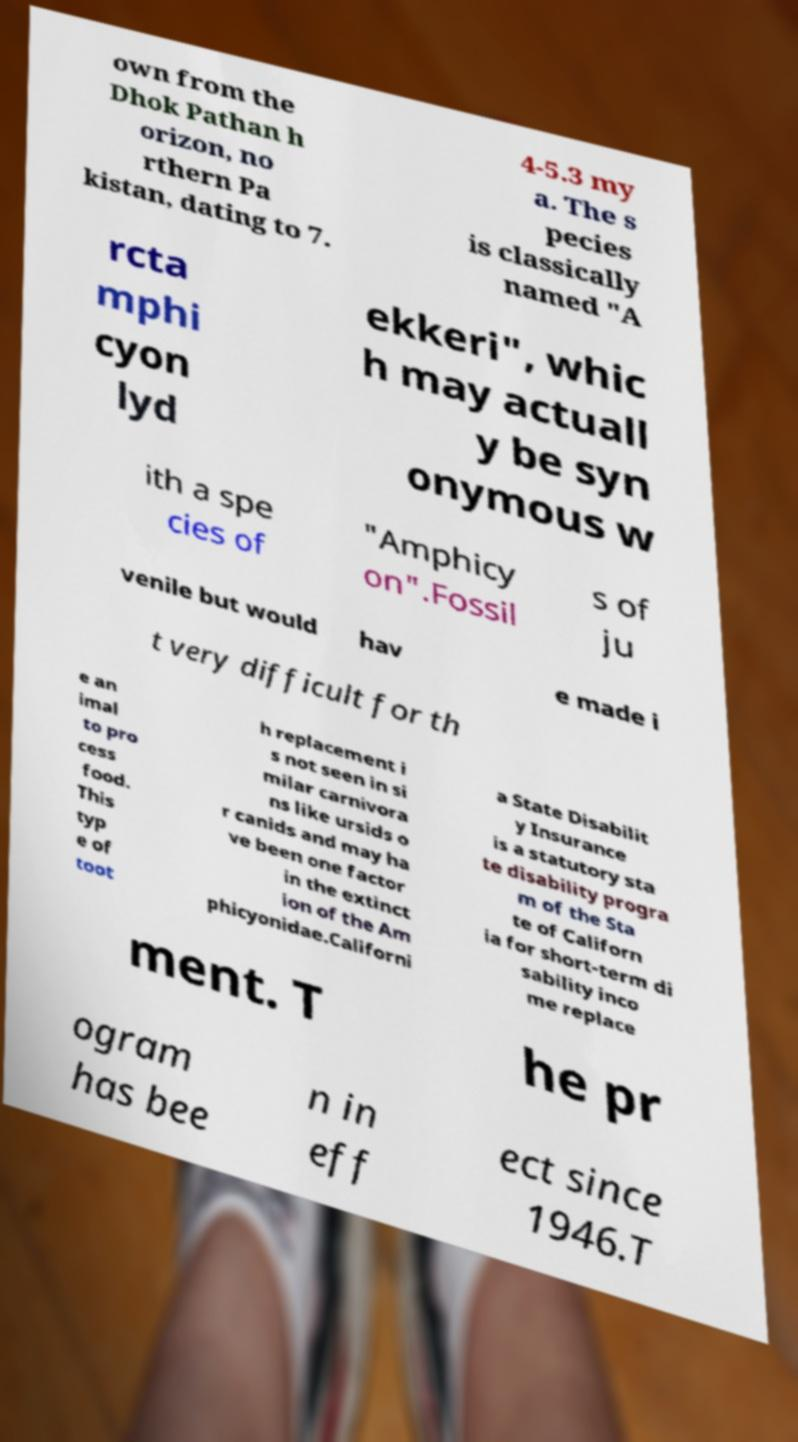Could you assist in decoding the text presented in this image and type it out clearly? own from the Dhok Pathan h orizon, no rthern Pa kistan, dating to 7. 4-5.3 my a. The s pecies is classically named "A rcta mphi cyon lyd ekkeri", whic h may actuall y be syn onymous w ith a spe cies of "Amphicy on".Fossil s of ju venile but would hav e made i t very difficult for th e an imal to pro cess food. This typ e of toot h replacement i s not seen in si milar carnivora ns like ursids o r canids and may ha ve been one factor in the extinct ion of the Am phicyonidae.Californi a State Disabilit y Insurance is a statutory sta te disability progra m of the Sta te of Californ ia for short-term di sability inco me replace ment. T he pr ogram has bee n in eff ect since 1946.T 